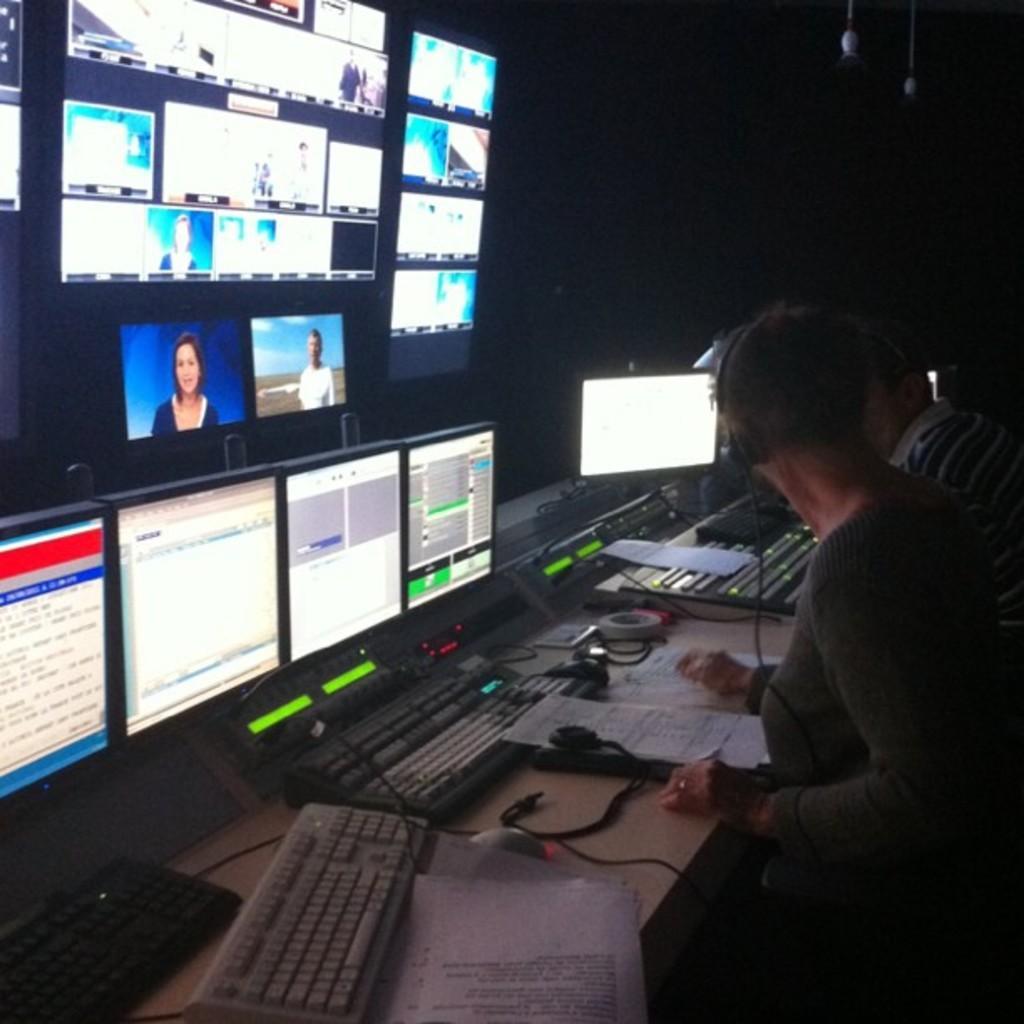Can you describe this image briefly? In this image, there are two persons wearing headset in front of the table contains keyboards and monitors. There are some screens in the top left of the image. 